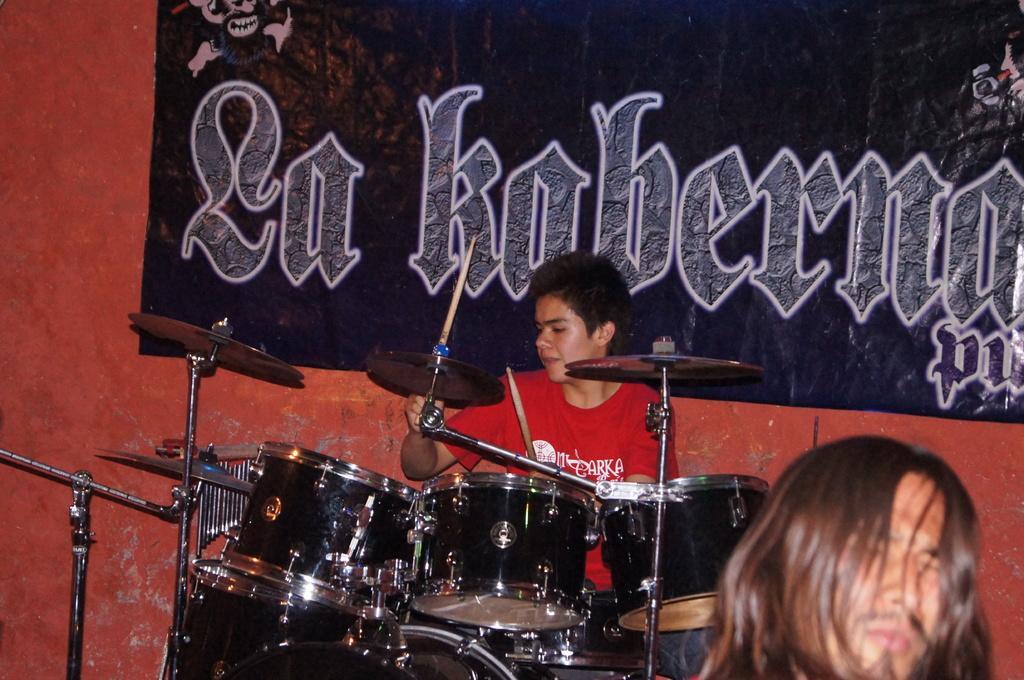Describe this image in one or two sentences. In this image, we can see a person sitting and holding stocks, we can see some music drums, in the background there is a poster. 